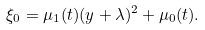<formula> <loc_0><loc_0><loc_500><loc_500>\xi _ { 0 } = \mu _ { 1 } ( t ) ( y + \lambda ) ^ { 2 } + \mu _ { 0 } ( t ) .</formula> 